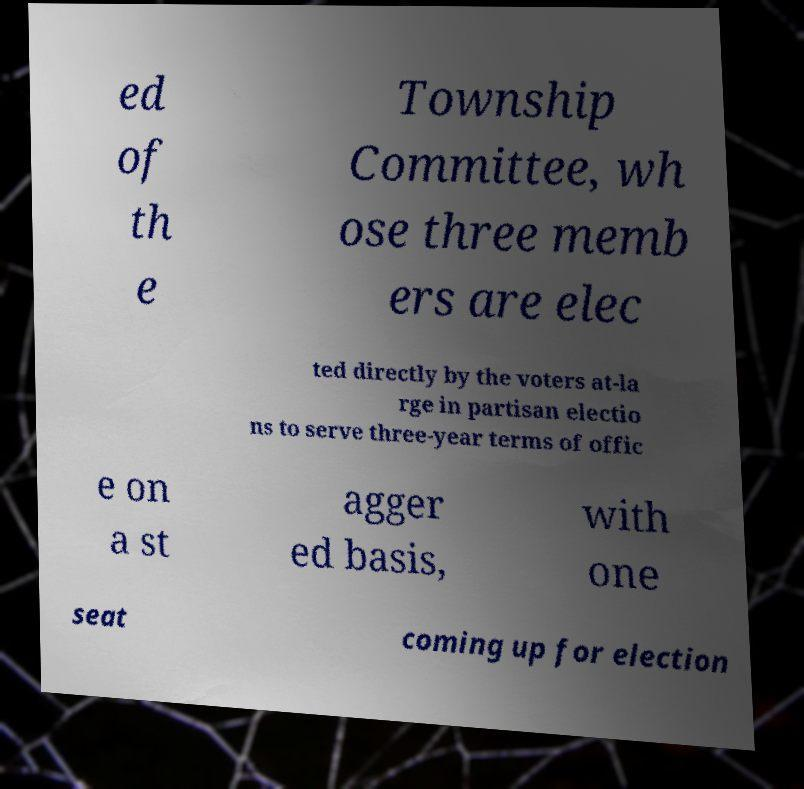Can you accurately transcribe the text from the provided image for me? ed of th e Township Committee, wh ose three memb ers are elec ted directly by the voters at-la rge in partisan electio ns to serve three-year terms of offic e on a st agger ed basis, with one seat coming up for election 